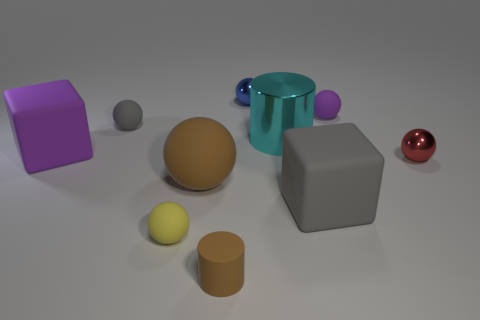Subtract all big balls. How many balls are left? 5 Subtract all brown cylinders. How many cylinders are left? 1 Subtract all balls. How many objects are left? 4 Subtract 2 cubes. How many cubes are left? 0 Subtract all brown cylinders. Subtract all big purple things. How many objects are left? 8 Add 7 brown cylinders. How many brown cylinders are left? 8 Add 7 purple blocks. How many purple blocks exist? 8 Subtract 1 blue balls. How many objects are left? 9 Subtract all green cylinders. Subtract all yellow cubes. How many cylinders are left? 2 